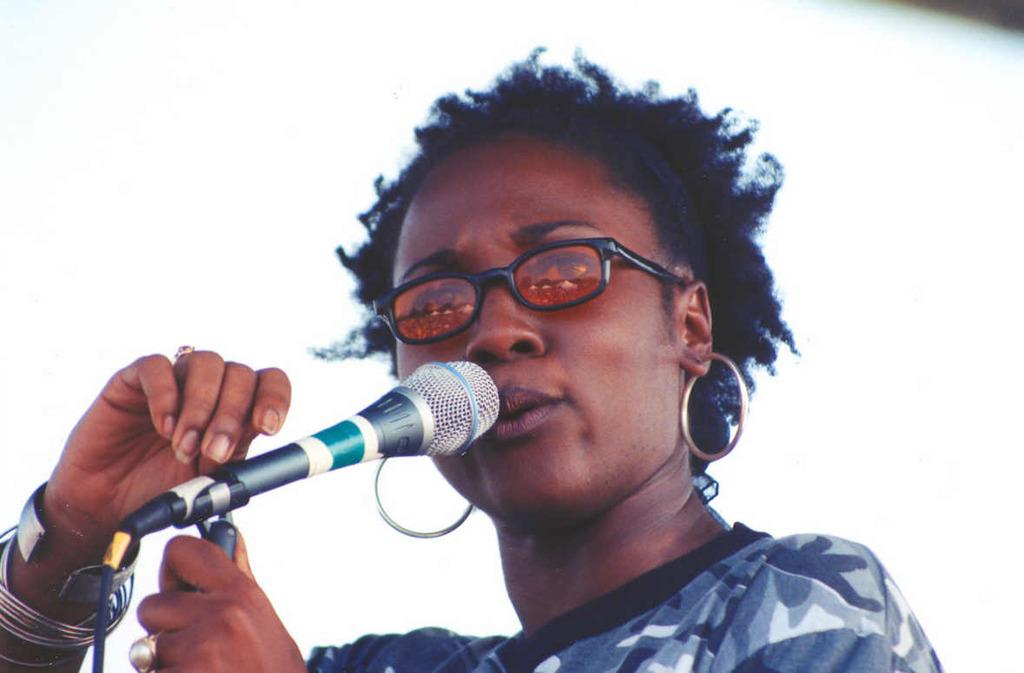Who is the main subject in the image? There is a woman in the image. What is the woman holding in the image? The woman is holding a microphone. What accessories is the woman wearing in the image? The woman is wearing glasses and earrings. What is the color of the background in the image? The background of the image is white. How many lizards can be seen crawling on the woman's shoulder in the image? There are no lizards present in the image. What month is it in the image? The month cannot be determined from the image, as it does not contain any information about the time of year. 